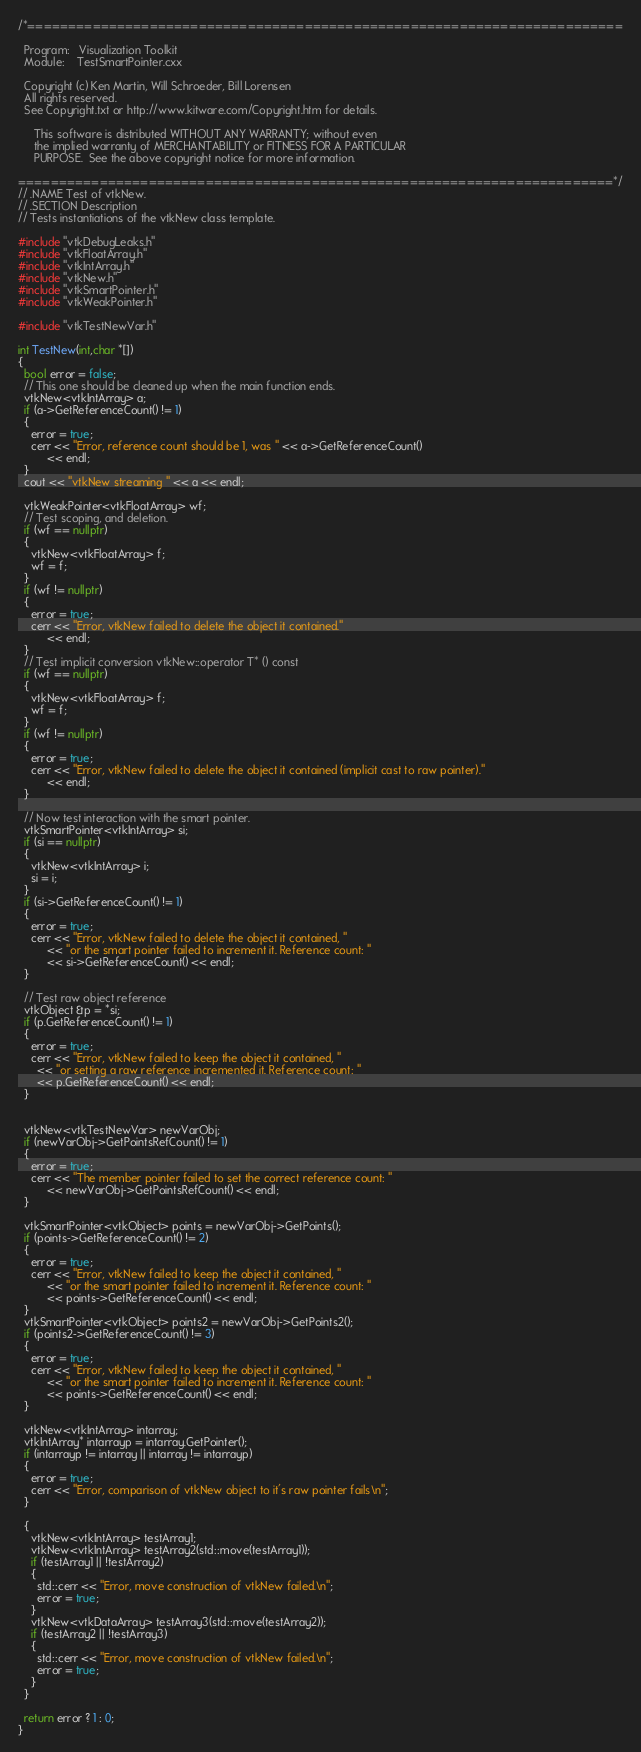<code> <loc_0><loc_0><loc_500><loc_500><_C++_>/*=========================================================================

  Program:   Visualization Toolkit
  Module:    TestSmartPointer.cxx

  Copyright (c) Ken Martin, Will Schroeder, Bill Lorensen
  All rights reserved.
  See Copyright.txt or http://www.kitware.com/Copyright.htm for details.

     This software is distributed WITHOUT ANY WARRANTY; without even
     the implied warranty of MERCHANTABILITY or FITNESS FOR A PARTICULAR
     PURPOSE.  See the above copyright notice for more information.

=========================================================================*/
// .NAME Test of vtkNew.
// .SECTION Description
// Tests instantiations of the vtkNew class template.

#include "vtkDebugLeaks.h"
#include "vtkFloatArray.h"
#include "vtkIntArray.h"
#include "vtkNew.h"
#include "vtkSmartPointer.h"
#include "vtkWeakPointer.h"

#include "vtkTestNewVar.h"

int TestNew(int,char *[])
{
  bool error = false;
  // This one should be cleaned up when the main function ends.
  vtkNew<vtkIntArray> a;
  if (a->GetReferenceCount() != 1)
  {
    error = true;
    cerr << "Error, reference count should be 1, was " << a->GetReferenceCount()
         << endl;
  }
  cout << "vtkNew streaming " << a << endl;

  vtkWeakPointer<vtkFloatArray> wf;
  // Test scoping, and deletion.
  if (wf == nullptr)
  {
    vtkNew<vtkFloatArray> f;
    wf = f;
  }
  if (wf != nullptr)
  {
    error = true;
    cerr << "Error, vtkNew failed to delete the object it contained."
         << endl;
  }
  // Test implicit conversion vtkNew::operator T* () const
  if (wf == nullptr)
  {
    vtkNew<vtkFloatArray> f;
    wf = f;
  }
  if (wf != nullptr)
  {
    error = true;
    cerr << "Error, vtkNew failed to delete the object it contained (implicit cast to raw pointer)."
         << endl;
  }

  // Now test interaction with the smart pointer.
  vtkSmartPointer<vtkIntArray> si;
  if (si == nullptr)
  {
    vtkNew<vtkIntArray> i;
    si = i;
  }
  if (si->GetReferenceCount() != 1)
  {
    error = true;
    cerr << "Error, vtkNew failed to delete the object it contained, "
         << "or the smart pointer failed to increment it. Reference count: "
         << si->GetReferenceCount() << endl;
  }

  // Test raw object reference
  vtkObject &p = *si;
  if (p.GetReferenceCount() != 1)
  {
    error = true;
    cerr << "Error, vtkNew failed to keep the object it contained, "
      << "or setting a raw reference incremented it. Reference count: "
      << p.GetReferenceCount() << endl;
  }


  vtkNew<vtkTestNewVar> newVarObj;
  if (newVarObj->GetPointsRefCount() != 1)
  {
    error = true;
    cerr << "The member pointer failed to set the correct reference count: "
         << newVarObj->GetPointsRefCount() << endl;
  }

  vtkSmartPointer<vtkObject> points = newVarObj->GetPoints();
  if (points->GetReferenceCount() != 2)
  {
    error = true;
    cerr << "Error, vtkNew failed to keep the object it contained, "
         << "or the smart pointer failed to increment it. Reference count: "
         << points->GetReferenceCount() << endl;
  }
  vtkSmartPointer<vtkObject> points2 = newVarObj->GetPoints2();
  if (points2->GetReferenceCount() != 3)
  {
    error = true;
    cerr << "Error, vtkNew failed to keep the object it contained, "
         << "or the smart pointer failed to increment it. Reference count: "
         << points->GetReferenceCount() << endl;
  }

  vtkNew<vtkIntArray> intarray;
  vtkIntArray* intarrayp = intarray.GetPointer();
  if (intarrayp != intarray || intarray != intarrayp)
  {
    error = true;
    cerr << "Error, comparison of vtkNew object to it's raw pointer fails\n";
  }

  {
    vtkNew<vtkIntArray> testArray1;
    vtkNew<vtkIntArray> testArray2(std::move(testArray1));
    if (testArray1 || !testArray2)
    {
      std::cerr << "Error, move construction of vtkNew failed.\n";
      error = true;
    }
    vtkNew<vtkDataArray> testArray3(std::move(testArray2));
    if (testArray2 || !testArray3)
    {
      std::cerr << "Error, move construction of vtkNew failed.\n";
      error = true;
    }
  }

  return error ? 1 : 0;
}
</code> 